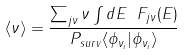Convert formula to latex. <formula><loc_0><loc_0><loc_500><loc_500>\left \langle \nu \right \rangle = \frac { \sum _ { j \nu } \nu \int d E \ F _ { j \nu } ( E ) } { P _ { s u r v } \langle \phi _ { \nu _ { i } } | \phi _ { \nu _ { i } } \rangle } \\</formula> 